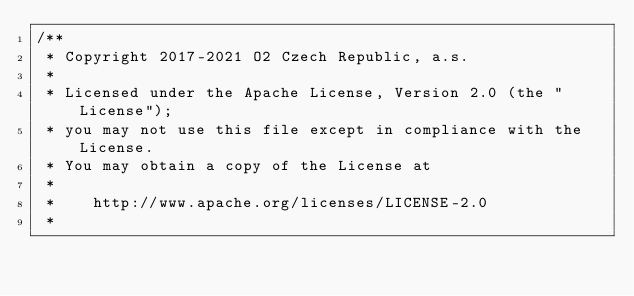<code> <loc_0><loc_0><loc_500><loc_500><_Java_>/**
 * Copyright 2017-2021 O2 Czech Republic, a.s.
 *
 * Licensed under the Apache License, Version 2.0 (the "License");
 * you may not use this file except in compliance with the License.
 * You may obtain a copy of the License at
 *
 *    http://www.apache.org/licenses/LICENSE-2.0
 *</code> 